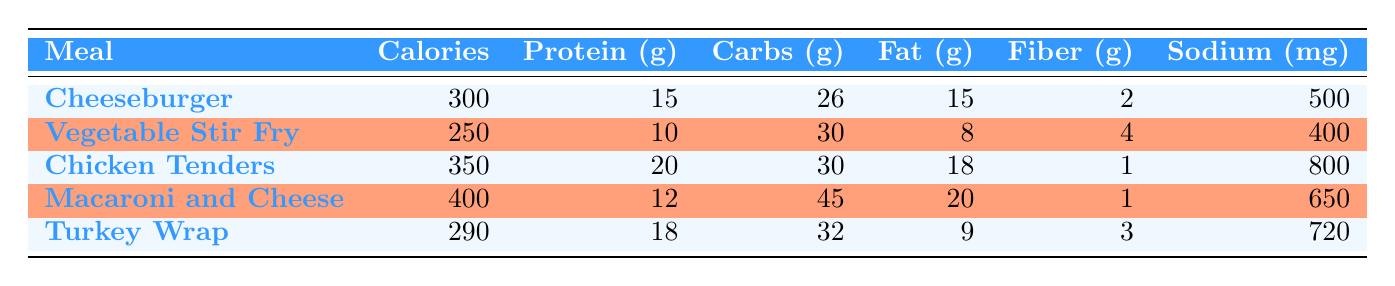What is the highest calorie meal option? By looking at the "Calories" column in the table, I can see the listed calorie values for each meal: 300 for Cheeseburger, 250 for Vegetable Stir Fry, 350 for Chicken Tenders, 400 for Macaroni and Cheese, and 290 for Turkey Wrap. The highest calorie meal is the one with the highest number, which is 400 for Macaroni and Cheese.
Answer: Macaroni and Cheese How much protein does the Turkey Wrap contain? To find the protein content in Turkey Wrap, I look at the row for Turkey Wrap in the "Protein (g)" column. It is clearly indicated as 18 grams.
Answer: 18 grams Which meal has the lowest amount of sodium? I compare the sodium levels for each meal: 500 mg for Cheeseburger, 400 mg for Vegetable Stir Fry, 800 mg for Chicken Tenders, 650 mg for Macaroni and Cheese, and 720 mg for Turkey Wrap. The lowest sodium content is 400 mg for Vegetable Stir Fry.
Answer: Vegetable Stir Fry What is the total carbohydrate content across all meal options? I will sum the carbohydrate values listed for each meal: 26 from Cheeseburger, 30 from Vegetable Stir Fry, 30 from Chicken Tenders, 45 from Macaroni and Cheese, and 32 from Turkey Wrap. The total is 26 + 30 + 30 + 45 + 32 = 163 grams of carbohydrates in total.
Answer: 163 grams Is the Chicken Tenders meal higher in fat than the Cheeseburger meal? First, I need to check the "Fat (g)" values for both meals. Chicken Tenders has 18 grams of fat, and Cheeseburger has 15 grams of fat. Since 18 is greater than 15, the Chicken Tenders meal is indeed higher in fat.
Answer: Yes What is the average protein content of all the meal options? I calculate the average protein by summing the protein contents: 15 for Cheeseburger, 10 for Vegetable Stir Fry, 20 for Chicken Tenders, 12 for Macaroni and Cheese, and 18 for Turkey Wrap. This gives a total of 15 + 10 + 20 + 12 + 18 = 85 grams of protein. Since there are 5 meals, I divide 85 by 5, which gives 17 grams as the average protein content.
Answer: 17 grams Which meal option has the most fiber? I examine the "Fiber (g)" column for each meal: Cheeseburger has 2, Vegetable Stir Fry has 4, Chicken Tenders has 1, Macaroni and Cheese has 1, and Turkey Wrap has 3. The highest fiber content is 4 grams found in Vegetable Stir Fry.
Answer: Vegetable Stir Fry Are there any meals that contain more than 700 mg of sodium? I look at the sodium values for each meal. The Cheeseburger has 500 mg, Vegetable Stir Fry has 400 mg, Chicken Tenders has 800 mg, Macaroni and Cheese has 650 mg, and Turkey Wrap has 720 mg. Since Chicken Tenders (800 mg) and Turkey Wrap (720 mg) are both above 700 mg, the answer is yes.
Answer: Yes 